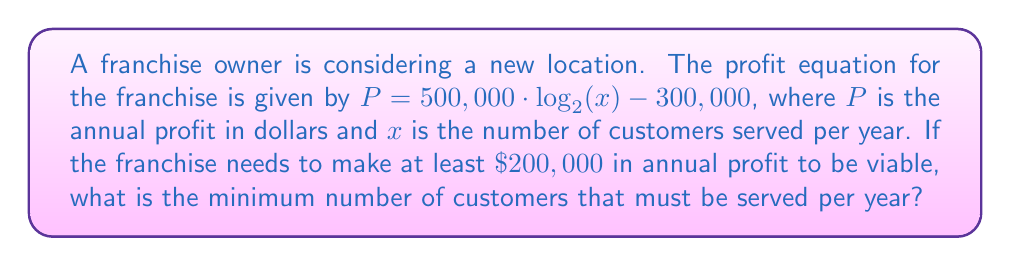What is the answer to this math problem? Let's solve this step-by-step:

1) We start with the equation:
   $P = 500,000 \cdot \log_2(x) - 300,000$

2) We know that $P$ must be at least $200,000$ for the franchise to be viable. So we can write:
   $200,000 = 500,000 \cdot \log_2(x) - 300,000$

3) Let's solve for $\log_2(x)$:
   $200,000 + 300,000 = 500,000 \cdot \log_2(x)$
   $500,000 = 500,000 \cdot \log_2(x)$

4) Divide both sides by 500,000:
   $1 = \log_2(x)$

5) To solve for $x$, we need to apply the inverse function (exponential) to both sides:
   $2^1 = 2^{\log_2(x)}$

6) Simplify:
   $2 = x$

Therefore, the franchise needs to serve at least 2 customers per year. However, this is not a realistic number for a viable business. In practice, the franchise owner would need to consider other factors and possibly adjust the profit equation or reconsider the viability of the location.
Answer: $x = 2$ customers per year 